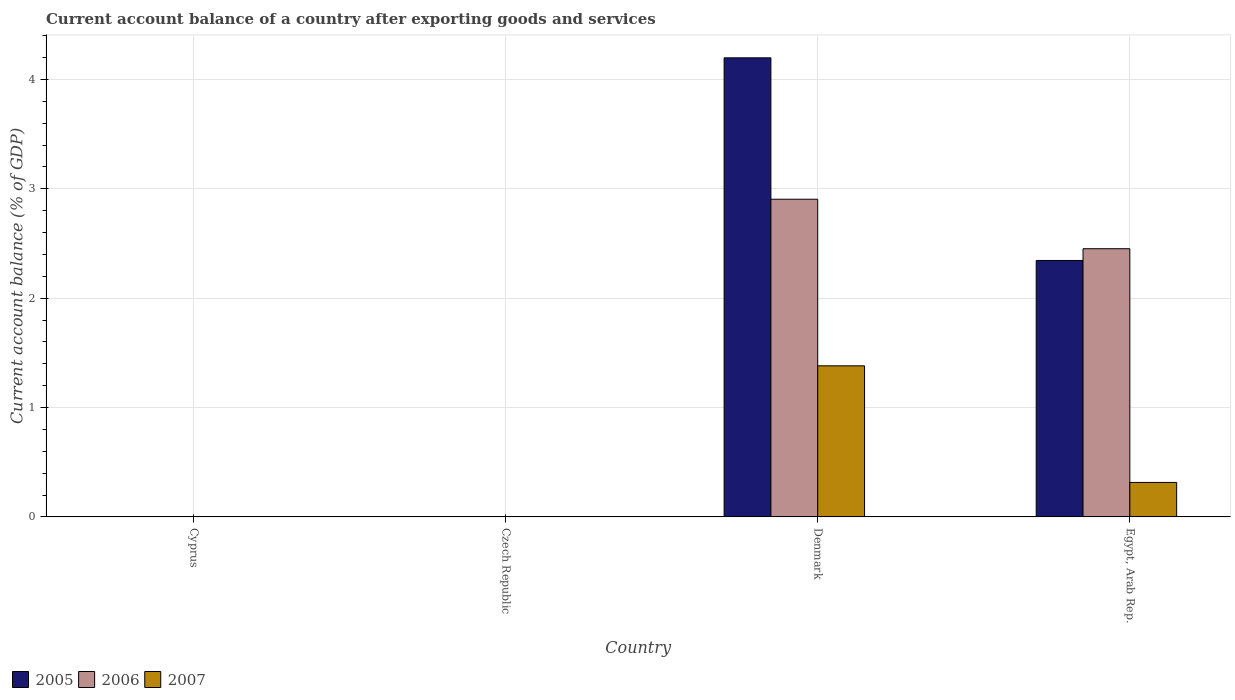How many different coloured bars are there?
Your response must be concise. 3. Are the number of bars per tick equal to the number of legend labels?
Give a very brief answer. No. How many bars are there on the 2nd tick from the left?
Give a very brief answer. 0. How many bars are there on the 4th tick from the right?
Keep it short and to the point. 0. What is the label of the 1st group of bars from the left?
Your response must be concise. Cyprus. What is the account balance in 2005 in Denmark?
Your response must be concise. 4.2. Across all countries, what is the maximum account balance in 2007?
Offer a very short reply. 1.38. What is the total account balance in 2005 in the graph?
Ensure brevity in your answer.  6.54. What is the difference between the account balance in 2006 in Egypt, Arab Rep. and the account balance in 2007 in Denmark?
Offer a very short reply. 1.07. What is the average account balance in 2005 per country?
Give a very brief answer. 1.64. What is the difference between the account balance of/in 2005 and account balance of/in 2007 in Denmark?
Provide a short and direct response. 2.82. In how many countries, is the account balance in 2007 greater than 2 %?
Ensure brevity in your answer.  0. What is the ratio of the account balance in 2006 in Denmark to that in Egypt, Arab Rep.?
Ensure brevity in your answer.  1.18. Is the account balance in 2006 in Denmark less than that in Egypt, Arab Rep.?
Your answer should be very brief. No. What is the difference between the highest and the lowest account balance in 2007?
Your answer should be very brief. 1.38. Is the sum of the account balance in 2005 in Denmark and Egypt, Arab Rep. greater than the maximum account balance in 2006 across all countries?
Keep it short and to the point. Yes. Are all the bars in the graph horizontal?
Give a very brief answer. No. How many countries are there in the graph?
Keep it short and to the point. 4. What is the difference between two consecutive major ticks on the Y-axis?
Keep it short and to the point. 1. Are the values on the major ticks of Y-axis written in scientific E-notation?
Offer a very short reply. No. Does the graph contain grids?
Make the answer very short. Yes. How are the legend labels stacked?
Your answer should be compact. Horizontal. What is the title of the graph?
Offer a terse response. Current account balance of a country after exporting goods and services. What is the label or title of the X-axis?
Ensure brevity in your answer.  Country. What is the label or title of the Y-axis?
Offer a very short reply. Current account balance (% of GDP). What is the Current account balance (% of GDP) in 2007 in Cyprus?
Your answer should be compact. 0. What is the Current account balance (% of GDP) in 2006 in Czech Republic?
Offer a very short reply. 0. What is the Current account balance (% of GDP) of 2005 in Denmark?
Keep it short and to the point. 4.2. What is the Current account balance (% of GDP) of 2006 in Denmark?
Your answer should be very brief. 2.9. What is the Current account balance (% of GDP) of 2007 in Denmark?
Offer a very short reply. 1.38. What is the Current account balance (% of GDP) in 2005 in Egypt, Arab Rep.?
Provide a succinct answer. 2.34. What is the Current account balance (% of GDP) in 2006 in Egypt, Arab Rep.?
Give a very brief answer. 2.45. What is the Current account balance (% of GDP) in 2007 in Egypt, Arab Rep.?
Provide a short and direct response. 0.32. Across all countries, what is the maximum Current account balance (% of GDP) in 2005?
Offer a terse response. 4.2. Across all countries, what is the maximum Current account balance (% of GDP) of 2006?
Keep it short and to the point. 2.9. Across all countries, what is the maximum Current account balance (% of GDP) of 2007?
Your response must be concise. 1.38. Across all countries, what is the minimum Current account balance (% of GDP) in 2005?
Offer a very short reply. 0. Across all countries, what is the minimum Current account balance (% of GDP) in 2007?
Your answer should be very brief. 0. What is the total Current account balance (% of GDP) of 2005 in the graph?
Your answer should be very brief. 6.54. What is the total Current account balance (% of GDP) of 2006 in the graph?
Offer a very short reply. 5.36. What is the total Current account balance (% of GDP) of 2007 in the graph?
Ensure brevity in your answer.  1.7. What is the difference between the Current account balance (% of GDP) of 2005 in Denmark and that in Egypt, Arab Rep.?
Your answer should be compact. 1.85. What is the difference between the Current account balance (% of GDP) in 2006 in Denmark and that in Egypt, Arab Rep.?
Make the answer very short. 0.45. What is the difference between the Current account balance (% of GDP) of 2007 in Denmark and that in Egypt, Arab Rep.?
Your response must be concise. 1.07. What is the difference between the Current account balance (% of GDP) in 2005 in Denmark and the Current account balance (% of GDP) in 2006 in Egypt, Arab Rep.?
Your response must be concise. 1.75. What is the difference between the Current account balance (% of GDP) in 2005 in Denmark and the Current account balance (% of GDP) in 2007 in Egypt, Arab Rep.?
Provide a succinct answer. 3.88. What is the difference between the Current account balance (% of GDP) of 2006 in Denmark and the Current account balance (% of GDP) of 2007 in Egypt, Arab Rep.?
Your response must be concise. 2.59. What is the average Current account balance (% of GDP) in 2005 per country?
Provide a short and direct response. 1.64. What is the average Current account balance (% of GDP) in 2006 per country?
Your response must be concise. 1.34. What is the average Current account balance (% of GDP) of 2007 per country?
Provide a short and direct response. 0.42. What is the difference between the Current account balance (% of GDP) in 2005 and Current account balance (% of GDP) in 2006 in Denmark?
Give a very brief answer. 1.29. What is the difference between the Current account balance (% of GDP) in 2005 and Current account balance (% of GDP) in 2007 in Denmark?
Your answer should be compact. 2.82. What is the difference between the Current account balance (% of GDP) in 2006 and Current account balance (% of GDP) in 2007 in Denmark?
Your answer should be compact. 1.52. What is the difference between the Current account balance (% of GDP) of 2005 and Current account balance (% of GDP) of 2006 in Egypt, Arab Rep.?
Make the answer very short. -0.11. What is the difference between the Current account balance (% of GDP) of 2005 and Current account balance (% of GDP) of 2007 in Egypt, Arab Rep.?
Give a very brief answer. 2.03. What is the difference between the Current account balance (% of GDP) of 2006 and Current account balance (% of GDP) of 2007 in Egypt, Arab Rep.?
Make the answer very short. 2.14. What is the ratio of the Current account balance (% of GDP) of 2005 in Denmark to that in Egypt, Arab Rep.?
Offer a terse response. 1.79. What is the ratio of the Current account balance (% of GDP) in 2006 in Denmark to that in Egypt, Arab Rep.?
Your answer should be compact. 1.18. What is the ratio of the Current account balance (% of GDP) in 2007 in Denmark to that in Egypt, Arab Rep.?
Your answer should be very brief. 4.38. What is the difference between the highest and the lowest Current account balance (% of GDP) in 2005?
Your response must be concise. 4.2. What is the difference between the highest and the lowest Current account balance (% of GDP) in 2006?
Your response must be concise. 2.9. What is the difference between the highest and the lowest Current account balance (% of GDP) in 2007?
Keep it short and to the point. 1.38. 